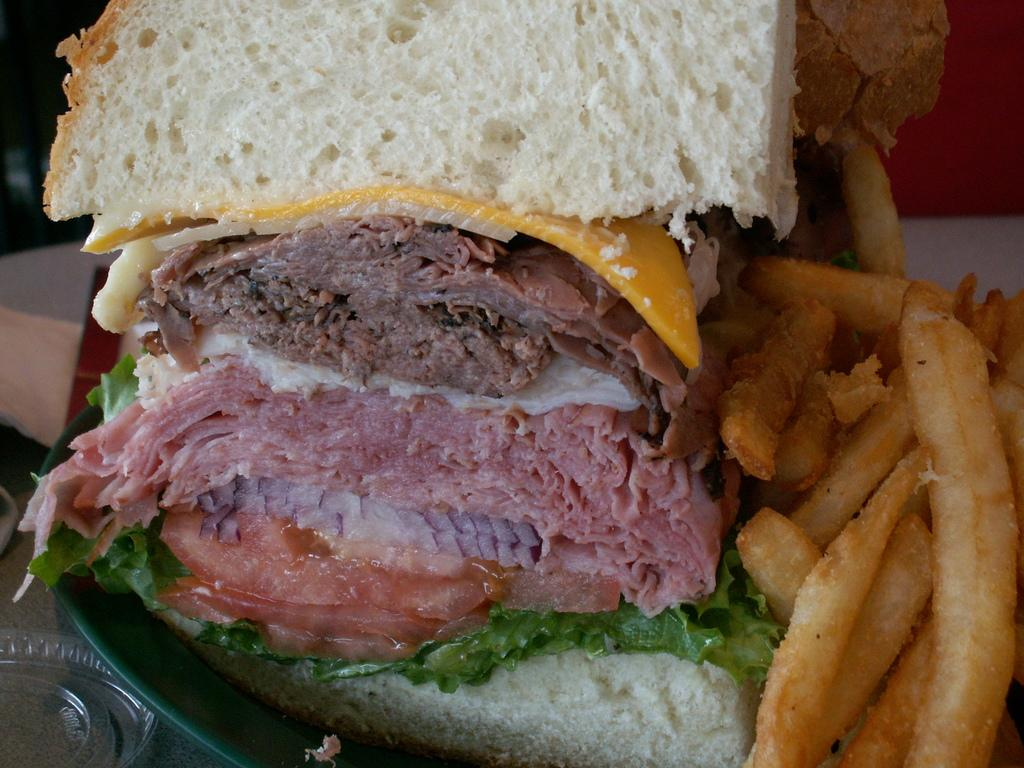What is located in the foreground of the image? There are food items in a plate in the foreground of the image. What type of creature can be seen crying in the image? There is no creature present in the image, let alone one that is crying. 